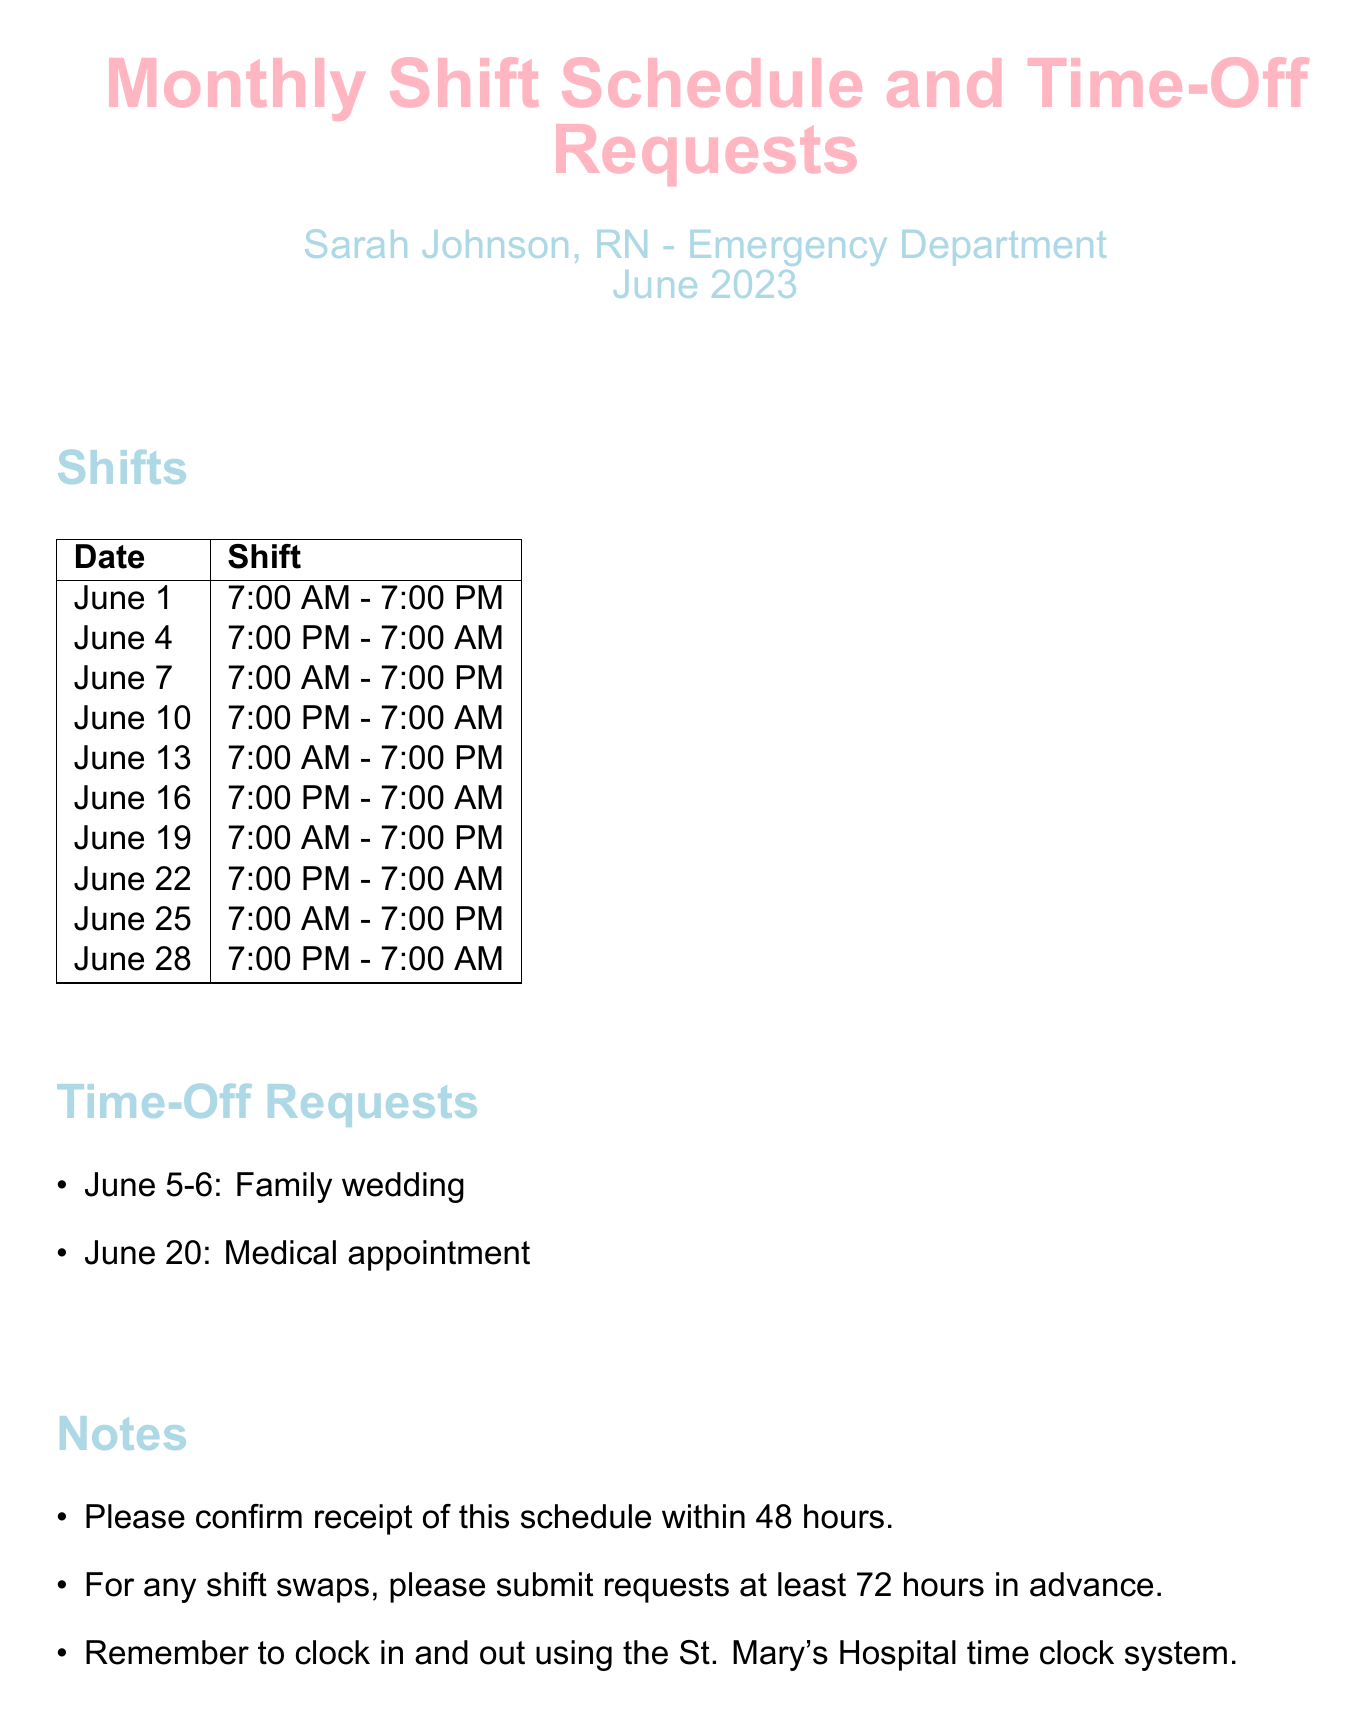What is the shift on June 1? The schedule indicates the shift for June 1 is from 7:00 AM to 7:00 PM.
Answer: 7:00 AM - 7:00 PM Who is the nurse manager? The document lists Linda Thompson as the Nurse Manager.
Answer: Linda Thompson What date is requested off for a family wedding? The time-off request for a family wedding is on June 5-6.
Answer: June 5-6 How many night shifts are scheduled in June? The document shows night shifts on June 4, 10, 16, 22, and 28, totaling five night shifts.
Answer: 5 What is the phone number for the nurse manager? The document provides the nurse manager's phone number as (555) 123-4567.
Answer: (555) 123-4567 On which date is there a medical appointment? The schedule indicates a medical appointment is requested on June 20.
Answer: June 20 What time should shift swap requests be submitted? Shift swap requests should be submitted at least 72 hours in advance, as stated in the notes.
Answer: 72 hours What color is used for the section titles? The section titles are colored in nurse blue.
Answer: nurse blue 